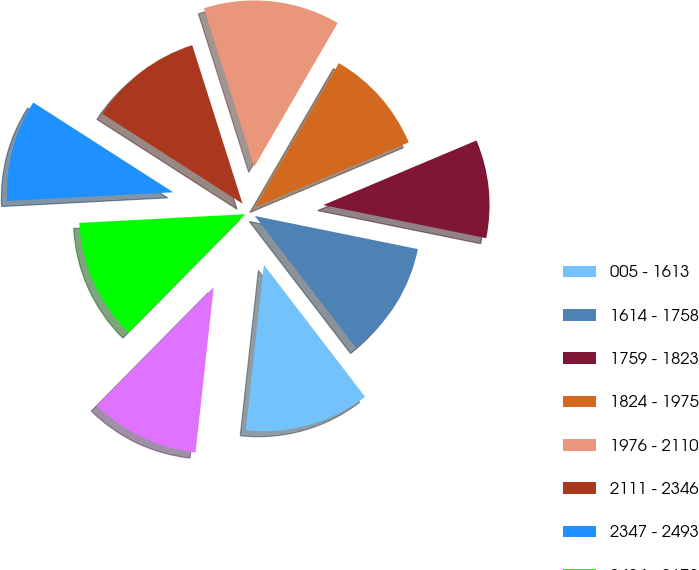Convert chart to OTSL. <chart><loc_0><loc_0><loc_500><loc_500><pie_chart><fcel>005 - 1613<fcel>1614 - 1758<fcel>1759 - 1823<fcel>1824 - 1975<fcel>1976 - 2110<fcel>2111 - 2346<fcel>2347 - 2493<fcel>2494 - 2673<fcel>2674 - 5326<nl><fcel>12.15%<fcel>11.4%<fcel>9.54%<fcel>10.28%<fcel>13.26%<fcel>11.03%<fcel>9.91%<fcel>11.77%<fcel>10.66%<nl></chart> 